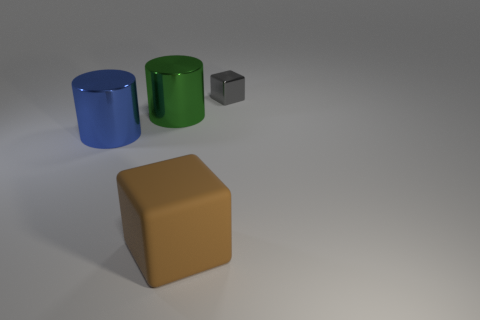Add 1 big shiny cylinders. How many objects exist? 5 Add 1 tiny gray cubes. How many tiny gray cubes are left? 2 Add 2 brown rubber blocks. How many brown rubber blocks exist? 3 Subtract 1 blue cylinders. How many objects are left? 3 Subtract all big blue metal cubes. Subtract all big green metal cylinders. How many objects are left? 3 